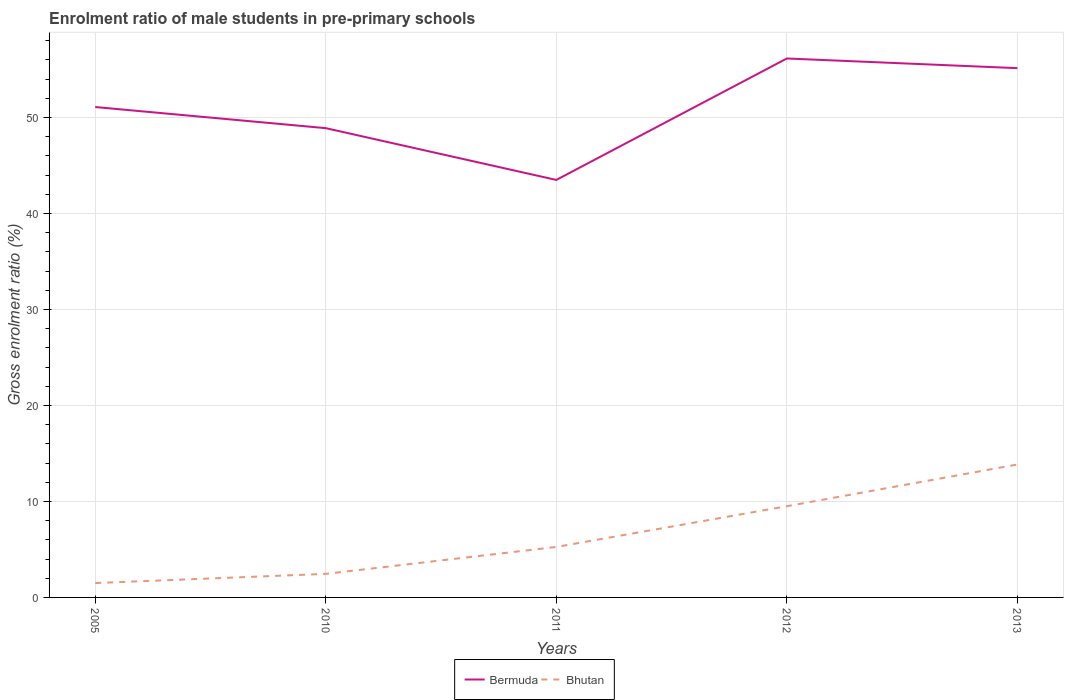Is the number of lines equal to the number of legend labels?
Offer a terse response. Yes. Across all years, what is the maximum enrolment ratio of male students in pre-primary schools in Bermuda?
Your answer should be very brief. 43.5. What is the total enrolment ratio of male students in pre-primary schools in Bermuda in the graph?
Ensure brevity in your answer.  1.01. What is the difference between the highest and the second highest enrolment ratio of male students in pre-primary schools in Bermuda?
Your answer should be very brief. 12.65. What is the difference between the highest and the lowest enrolment ratio of male students in pre-primary schools in Bhutan?
Offer a very short reply. 2. How many lines are there?
Provide a succinct answer. 2. Are the values on the major ticks of Y-axis written in scientific E-notation?
Offer a terse response. No. Where does the legend appear in the graph?
Provide a short and direct response. Bottom center. How are the legend labels stacked?
Provide a succinct answer. Horizontal. What is the title of the graph?
Your answer should be very brief. Enrolment ratio of male students in pre-primary schools. What is the label or title of the X-axis?
Make the answer very short. Years. What is the Gross enrolment ratio (%) of Bermuda in 2005?
Provide a succinct answer. 51.09. What is the Gross enrolment ratio (%) of Bhutan in 2005?
Your response must be concise. 1.5. What is the Gross enrolment ratio (%) in Bermuda in 2010?
Make the answer very short. 48.89. What is the Gross enrolment ratio (%) in Bhutan in 2010?
Give a very brief answer. 2.46. What is the Gross enrolment ratio (%) of Bermuda in 2011?
Provide a succinct answer. 43.5. What is the Gross enrolment ratio (%) in Bhutan in 2011?
Make the answer very short. 5.26. What is the Gross enrolment ratio (%) in Bermuda in 2012?
Make the answer very short. 56.15. What is the Gross enrolment ratio (%) of Bhutan in 2012?
Your answer should be very brief. 9.5. What is the Gross enrolment ratio (%) in Bermuda in 2013?
Your response must be concise. 55.15. What is the Gross enrolment ratio (%) in Bhutan in 2013?
Your answer should be very brief. 13.85. Across all years, what is the maximum Gross enrolment ratio (%) of Bermuda?
Your response must be concise. 56.15. Across all years, what is the maximum Gross enrolment ratio (%) in Bhutan?
Your answer should be very brief. 13.85. Across all years, what is the minimum Gross enrolment ratio (%) in Bermuda?
Your response must be concise. 43.5. Across all years, what is the minimum Gross enrolment ratio (%) of Bhutan?
Keep it short and to the point. 1.5. What is the total Gross enrolment ratio (%) of Bermuda in the graph?
Your answer should be very brief. 254.79. What is the total Gross enrolment ratio (%) in Bhutan in the graph?
Provide a short and direct response. 32.56. What is the difference between the Gross enrolment ratio (%) of Bermuda in 2005 and that in 2010?
Offer a terse response. 2.2. What is the difference between the Gross enrolment ratio (%) of Bhutan in 2005 and that in 2010?
Provide a succinct answer. -0.96. What is the difference between the Gross enrolment ratio (%) in Bermuda in 2005 and that in 2011?
Keep it short and to the point. 7.59. What is the difference between the Gross enrolment ratio (%) of Bhutan in 2005 and that in 2011?
Give a very brief answer. -3.76. What is the difference between the Gross enrolment ratio (%) in Bermuda in 2005 and that in 2012?
Make the answer very short. -5.06. What is the difference between the Gross enrolment ratio (%) in Bhutan in 2005 and that in 2012?
Ensure brevity in your answer.  -8.01. What is the difference between the Gross enrolment ratio (%) in Bermuda in 2005 and that in 2013?
Give a very brief answer. -4.05. What is the difference between the Gross enrolment ratio (%) in Bhutan in 2005 and that in 2013?
Make the answer very short. -12.35. What is the difference between the Gross enrolment ratio (%) in Bermuda in 2010 and that in 2011?
Your response must be concise. 5.39. What is the difference between the Gross enrolment ratio (%) of Bhutan in 2010 and that in 2011?
Ensure brevity in your answer.  -2.8. What is the difference between the Gross enrolment ratio (%) of Bermuda in 2010 and that in 2012?
Your response must be concise. -7.26. What is the difference between the Gross enrolment ratio (%) of Bhutan in 2010 and that in 2012?
Your answer should be very brief. -7.05. What is the difference between the Gross enrolment ratio (%) in Bermuda in 2010 and that in 2013?
Provide a succinct answer. -6.25. What is the difference between the Gross enrolment ratio (%) in Bhutan in 2010 and that in 2013?
Provide a short and direct response. -11.39. What is the difference between the Gross enrolment ratio (%) of Bermuda in 2011 and that in 2012?
Provide a short and direct response. -12.65. What is the difference between the Gross enrolment ratio (%) in Bhutan in 2011 and that in 2012?
Provide a succinct answer. -4.25. What is the difference between the Gross enrolment ratio (%) in Bermuda in 2011 and that in 2013?
Ensure brevity in your answer.  -11.65. What is the difference between the Gross enrolment ratio (%) in Bhutan in 2011 and that in 2013?
Make the answer very short. -8.59. What is the difference between the Gross enrolment ratio (%) of Bermuda in 2012 and that in 2013?
Offer a terse response. 1.01. What is the difference between the Gross enrolment ratio (%) in Bhutan in 2012 and that in 2013?
Keep it short and to the point. -4.34. What is the difference between the Gross enrolment ratio (%) in Bermuda in 2005 and the Gross enrolment ratio (%) in Bhutan in 2010?
Make the answer very short. 48.64. What is the difference between the Gross enrolment ratio (%) in Bermuda in 2005 and the Gross enrolment ratio (%) in Bhutan in 2011?
Your answer should be very brief. 45.84. What is the difference between the Gross enrolment ratio (%) in Bermuda in 2005 and the Gross enrolment ratio (%) in Bhutan in 2012?
Your answer should be compact. 41.59. What is the difference between the Gross enrolment ratio (%) in Bermuda in 2005 and the Gross enrolment ratio (%) in Bhutan in 2013?
Your answer should be very brief. 37.25. What is the difference between the Gross enrolment ratio (%) in Bermuda in 2010 and the Gross enrolment ratio (%) in Bhutan in 2011?
Provide a succinct answer. 43.64. What is the difference between the Gross enrolment ratio (%) of Bermuda in 2010 and the Gross enrolment ratio (%) of Bhutan in 2012?
Provide a short and direct response. 39.39. What is the difference between the Gross enrolment ratio (%) of Bermuda in 2010 and the Gross enrolment ratio (%) of Bhutan in 2013?
Your answer should be very brief. 35.05. What is the difference between the Gross enrolment ratio (%) of Bermuda in 2011 and the Gross enrolment ratio (%) of Bhutan in 2012?
Your response must be concise. 34. What is the difference between the Gross enrolment ratio (%) of Bermuda in 2011 and the Gross enrolment ratio (%) of Bhutan in 2013?
Keep it short and to the point. 29.65. What is the difference between the Gross enrolment ratio (%) in Bermuda in 2012 and the Gross enrolment ratio (%) in Bhutan in 2013?
Make the answer very short. 42.31. What is the average Gross enrolment ratio (%) of Bermuda per year?
Offer a very short reply. 50.96. What is the average Gross enrolment ratio (%) of Bhutan per year?
Ensure brevity in your answer.  6.51. In the year 2005, what is the difference between the Gross enrolment ratio (%) of Bermuda and Gross enrolment ratio (%) of Bhutan?
Provide a short and direct response. 49.6. In the year 2010, what is the difference between the Gross enrolment ratio (%) in Bermuda and Gross enrolment ratio (%) in Bhutan?
Provide a short and direct response. 46.44. In the year 2011, what is the difference between the Gross enrolment ratio (%) in Bermuda and Gross enrolment ratio (%) in Bhutan?
Your response must be concise. 38.24. In the year 2012, what is the difference between the Gross enrolment ratio (%) in Bermuda and Gross enrolment ratio (%) in Bhutan?
Give a very brief answer. 46.65. In the year 2013, what is the difference between the Gross enrolment ratio (%) in Bermuda and Gross enrolment ratio (%) in Bhutan?
Give a very brief answer. 41.3. What is the ratio of the Gross enrolment ratio (%) of Bermuda in 2005 to that in 2010?
Ensure brevity in your answer.  1.04. What is the ratio of the Gross enrolment ratio (%) in Bhutan in 2005 to that in 2010?
Make the answer very short. 0.61. What is the ratio of the Gross enrolment ratio (%) in Bermuda in 2005 to that in 2011?
Your answer should be very brief. 1.17. What is the ratio of the Gross enrolment ratio (%) in Bhutan in 2005 to that in 2011?
Your answer should be very brief. 0.28. What is the ratio of the Gross enrolment ratio (%) in Bermuda in 2005 to that in 2012?
Provide a succinct answer. 0.91. What is the ratio of the Gross enrolment ratio (%) in Bhutan in 2005 to that in 2012?
Your response must be concise. 0.16. What is the ratio of the Gross enrolment ratio (%) in Bermuda in 2005 to that in 2013?
Provide a succinct answer. 0.93. What is the ratio of the Gross enrolment ratio (%) of Bhutan in 2005 to that in 2013?
Provide a short and direct response. 0.11. What is the ratio of the Gross enrolment ratio (%) of Bermuda in 2010 to that in 2011?
Give a very brief answer. 1.12. What is the ratio of the Gross enrolment ratio (%) in Bhutan in 2010 to that in 2011?
Provide a short and direct response. 0.47. What is the ratio of the Gross enrolment ratio (%) in Bermuda in 2010 to that in 2012?
Ensure brevity in your answer.  0.87. What is the ratio of the Gross enrolment ratio (%) of Bhutan in 2010 to that in 2012?
Your answer should be compact. 0.26. What is the ratio of the Gross enrolment ratio (%) in Bermuda in 2010 to that in 2013?
Offer a very short reply. 0.89. What is the ratio of the Gross enrolment ratio (%) in Bhutan in 2010 to that in 2013?
Keep it short and to the point. 0.18. What is the ratio of the Gross enrolment ratio (%) of Bermuda in 2011 to that in 2012?
Your answer should be very brief. 0.77. What is the ratio of the Gross enrolment ratio (%) of Bhutan in 2011 to that in 2012?
Provide a succinct answer. 0.55. What is the ratio of the Gross enrolment ratio (%) in Bermuda in 2011 to that in 2013?
Offer a very short reply. 0.79. What is the ratio of the Gross enrolment ratio (%) in Bhutan in 2011 to that in 2013?
Make the answer very short. 0.38. What is the ratio of the Gross enrolment ratio (%) in Bermuda in 2012 to that in 2013?
Your answer should be very brief. 1.02. What is the ratio of the Gross enrolment ratio (%) of Bhutan in 2012 to that in 2013?
Keep it short and to the point. 0.69. What is the difference between the highest and the second highest Gross enrolment ratio (%) of Bermuda?
Ensure brevity in your answer.  1.01. What is the difference between the highest and the second highest Gross enrolment ratio (%) of Bhutan?
Make the answer very short. 4.34. What is the difference between the highest and the lowest Gross enrolment ratio (%) in Bermuda?
Ensure brevity in your answer.  12.65. What is the difference between the highest and the lowest Gross enrolment ratio (%) in Bhutan?
Make the answer very short. 12.35. 